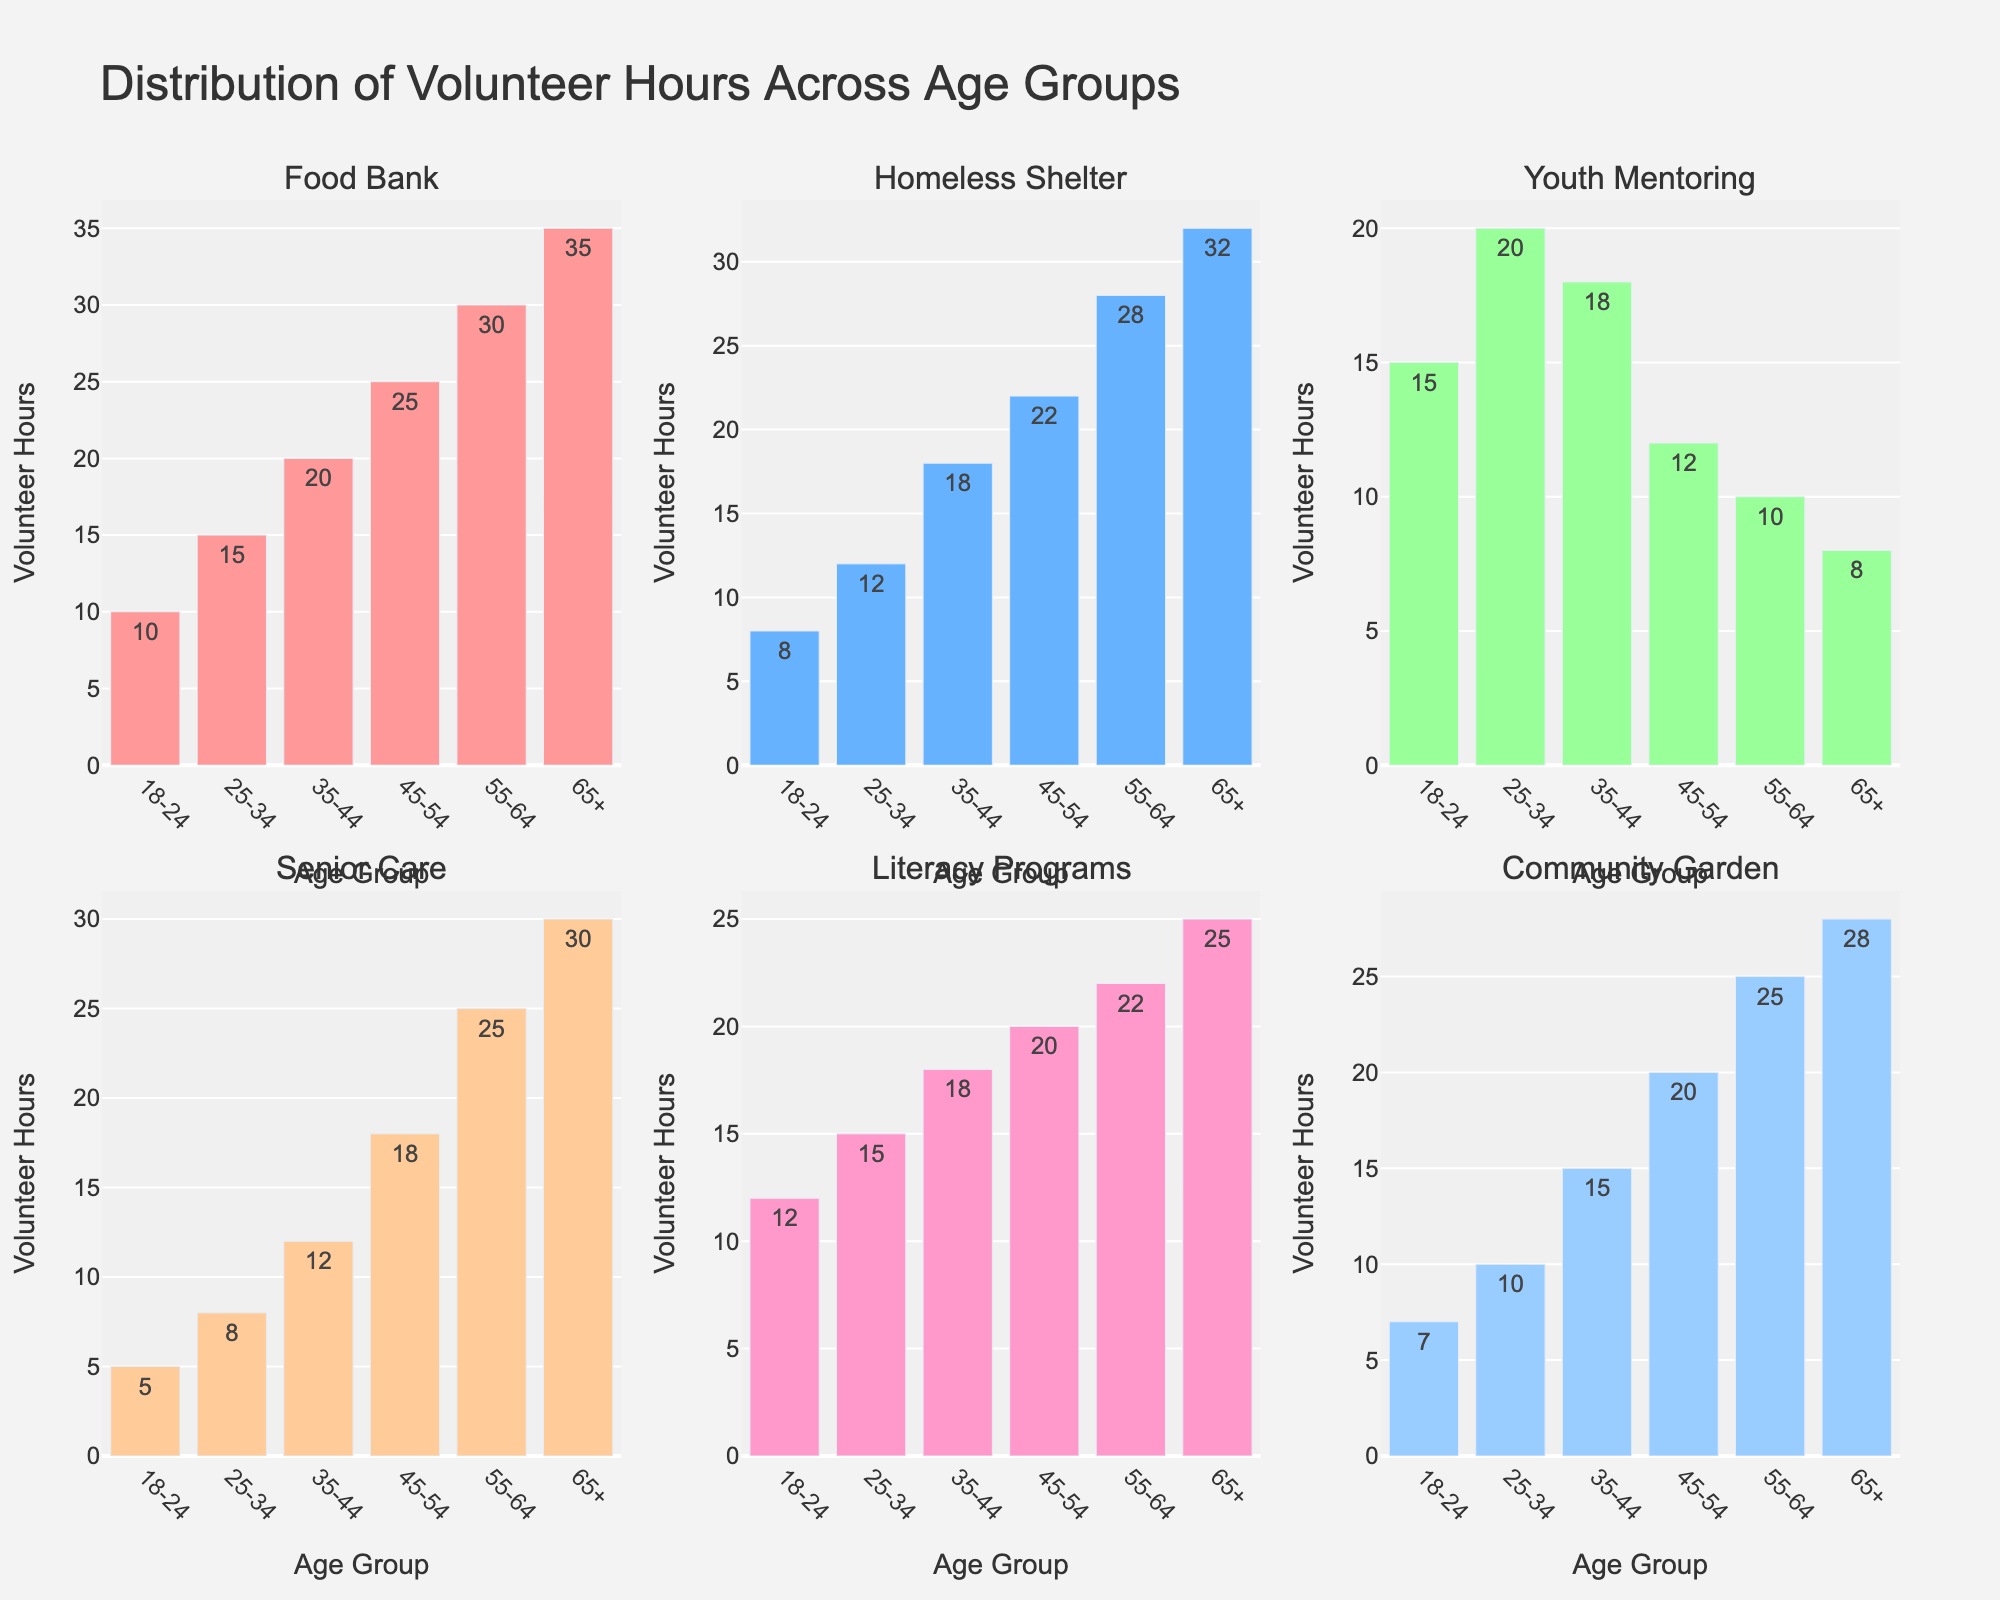What is the title of the chart? The title is displayed at the top of the chart. The title reads: "Distribution of Volunteer Hours Across Age Groups."
Answer: Distribution of Volunteer Hours Across Age Groups Which age group volunteered the most hours for Food Bank initiatives? Referring to the Food Bank subplot (first subplot on the top left), the highest bar represents the age group 65+ with 35 volunteer hours.
Answer: 65+ How many age groups are represented in each subplot? Each subplot has horizontal bars, with each bar corresponding to a different age group. The x-axis displays six age groups: 18-24, 25-34, 35-44, 45-54, 55-64, and 65+.
Answer: 6 Comparing the subplots, which initiative had the least volunteer hours in the 18-24 age group? Each subplot shows different initiatives with bars at different heights. The shortest bar for the 18-24 age group is in the Senior Care subplot with 5 hours.
Answer: Senior Care What is the combined total volunteer hours for the 55-64 age group across all initiatives? Adding up the 55-64 hours from all subplots: Food Bank (30) + Homeless Shelter (28) + Youth Mentoring (10) + Senior Care (25) + Literacy Programs (22) + Community Garden (25) = 140.
Answer: 140 For the Community Garden initiative, how much more did the 65+ age group volunteer hours compare to the 18-24 age group? The Community Garden subplot shows 65+ volunteered 28 hours and 18-24 volunteered 7 hours. So, the difference is 28 - 7 = 21 hours.
Answer: 21 hours What is the average number of volunteer hours for the 45-54 age group? Sum the hours of the 45-54 age group across all subplots: 25 (Food Bank) + 22 (Homeless Shelter) + 12 (Youth Mentoring) + 18 (Senior Care) + 20 (Literacy Programs) + 20 (Community Garden) = 117 hours. Divide by 6 subplots: 117 / 6 = 19.5.
Answer: 19.5 hours Which age group has the most consistent volunteer hours across all initiatives, and what is the variance of its contributions? The 35-44 age group is the most consistent, with hours being 20 (Food Bank), 18 (Homeless Shelter), 18 (Youth Mentoring), 12 (Senior Care), 18 (Literacy Programs), and 15 (Community Garden). Variance calculation steps: 1) Calculate the mean: (20 + 18 + 18 + 12 + 18 + 15) / 6 = 16.833. 2) Calculate the squared differences from the mean: (20-16.833)^2 + (18-16.833)^2 + (18-16.833)^2 + (12-16.833)^2 + (18-16.833)^2 + (15-16.833)^2. 3) Find the average of these squared differences: (10.028 + 1.361 + 1.361 + 23.361 + 1.361 + 3.028) / 6 ≈ 6.75.
Answer: 35-44, 6.75 